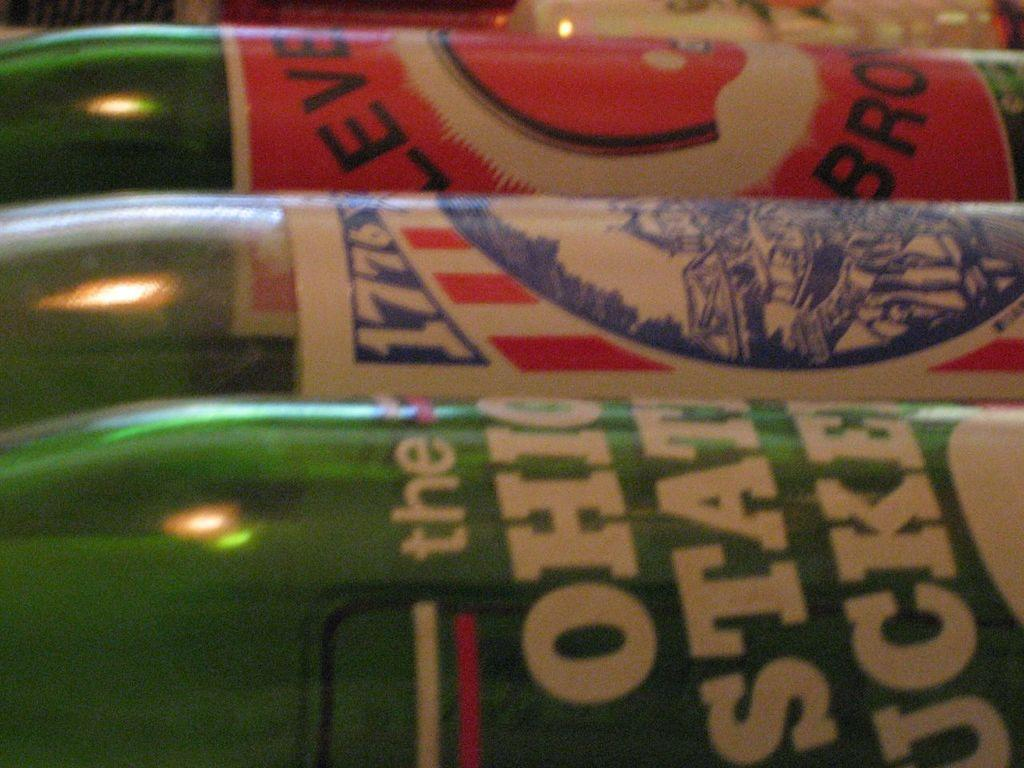<image>
Give a short and clear explanation of the subsequent image. Novelty bottles of soda are on their side, one reads Ohio State Buckeyes. 